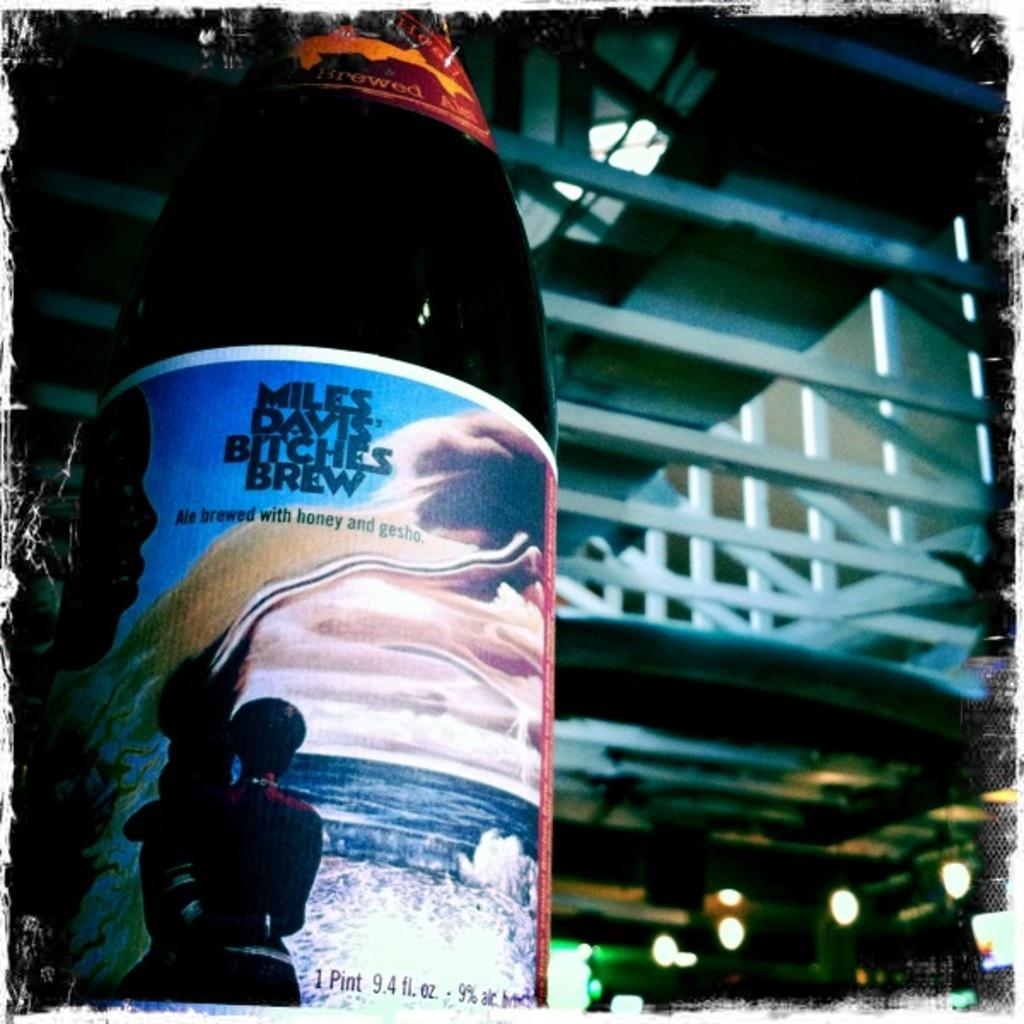<image>
Provide a brief description of the given image. A pint of Miles Davis' Bitches Brew with woman standing near the ocean on the label. 